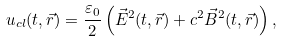Convert formula to latex. <formula><loc_0><loc_0><loc_500><loc_500>u _ { c l } ( t , \vec { r } ) = \frac { \varepsilon _ { 0 } } { 2 } \left ( \vec { E } ^ { 2 } ( t , \vec { r } ) + c ^ { 2 } \vec { B } ^ { 2 } ( t , \vec { r } ) \right ) ,</formula> 